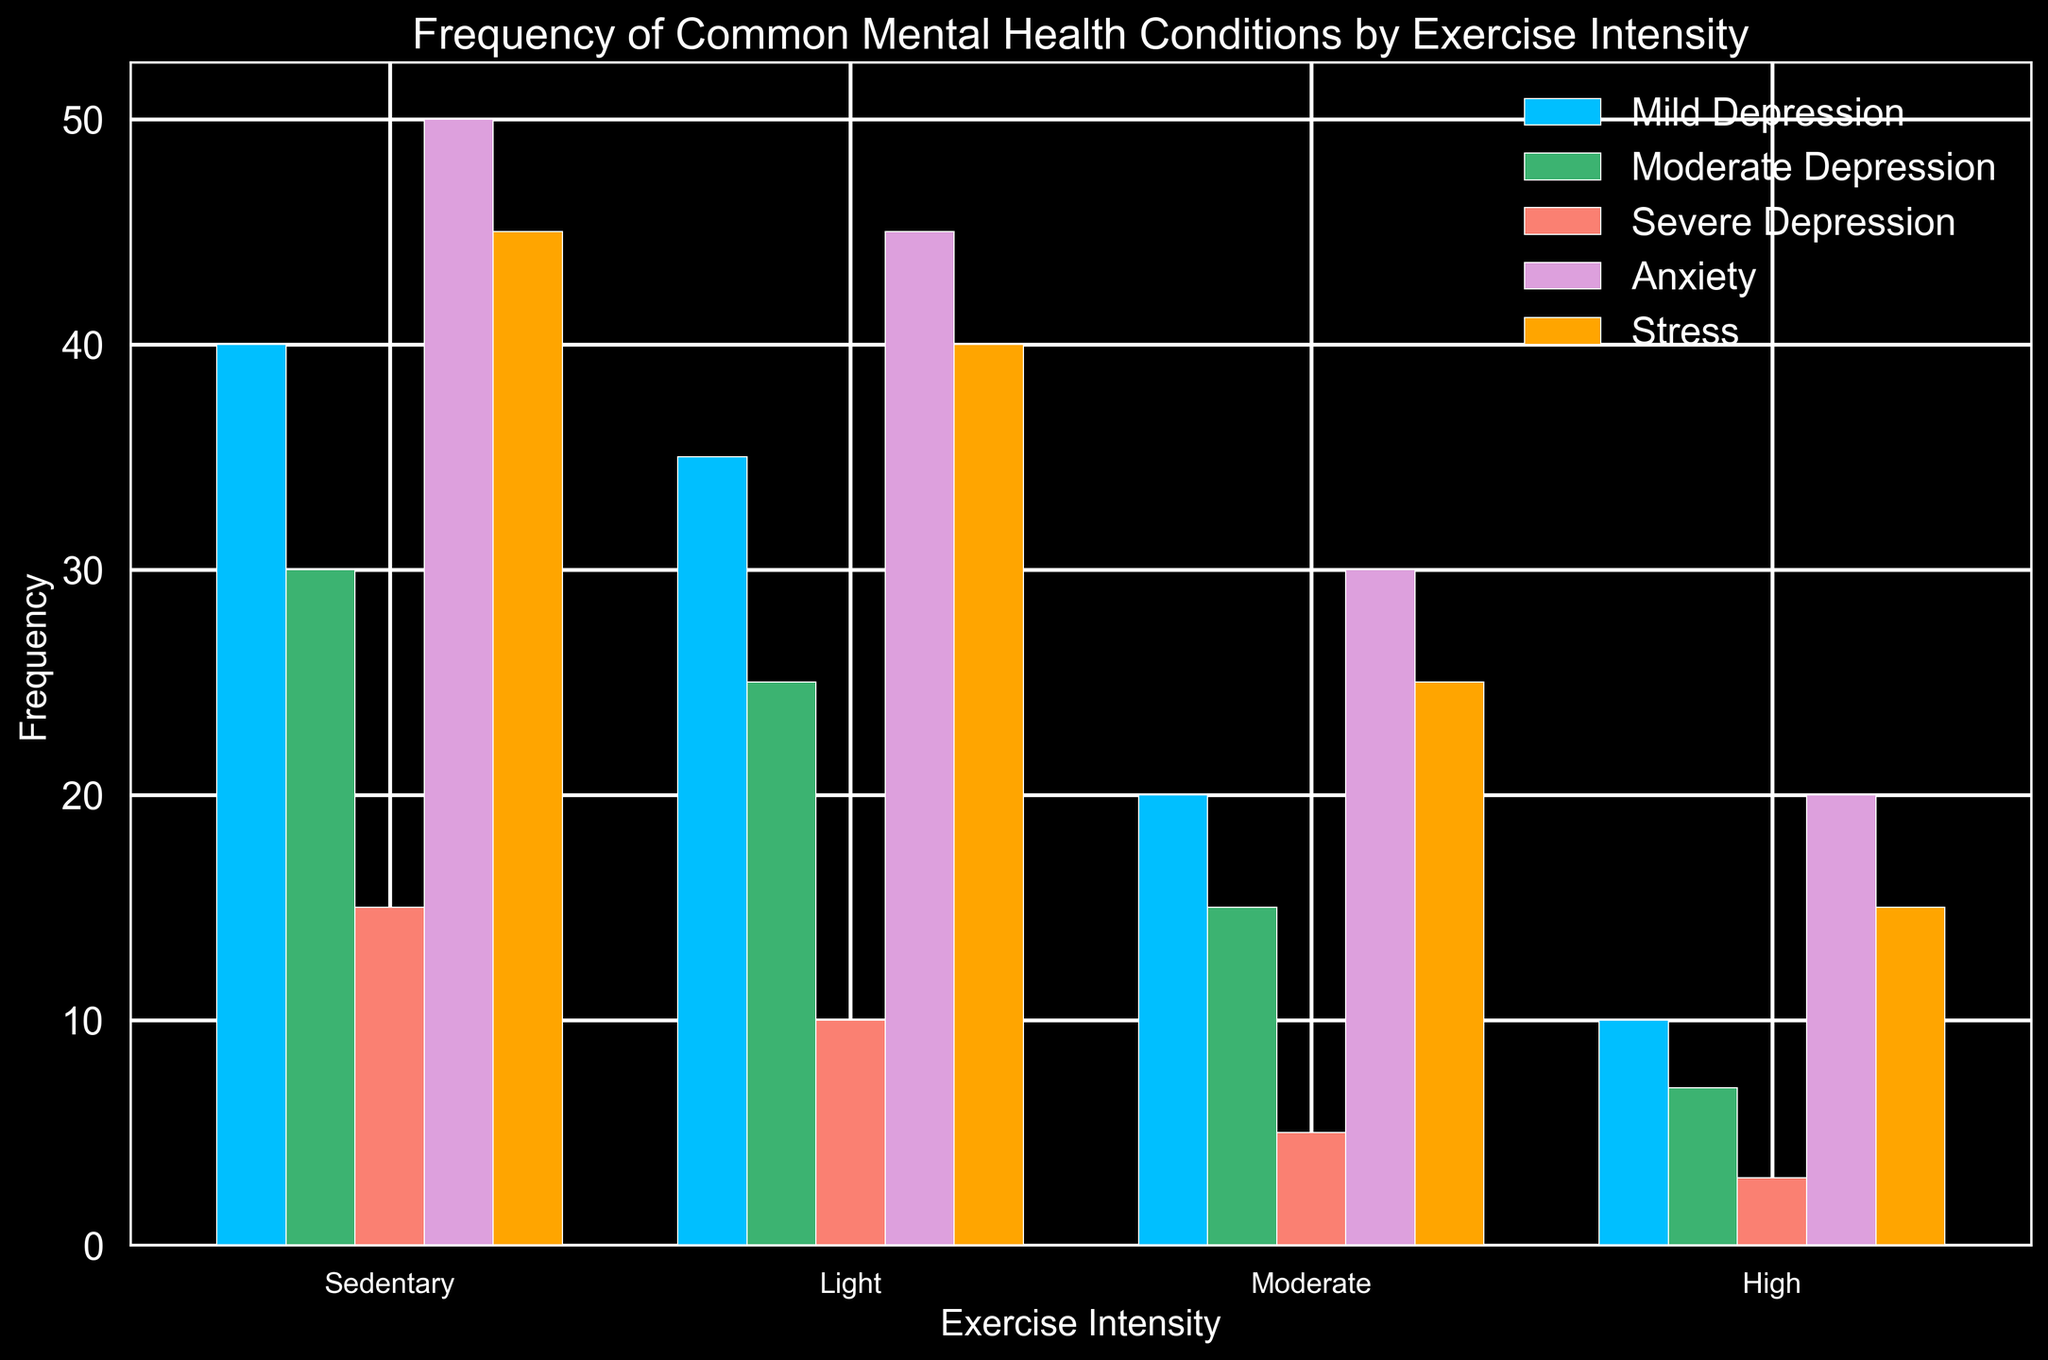What is the trend in the frequency of anxiety as exercise intensity increases? The height of the light purple bars that represent anxiety diminishes as exercise intensity increases from sedentary to high intensity. Specifically, anxiety frequency decreases from 50 in sedentary to 20 in high intensity.
Answer: Anxiety frequency decreases as exercise intensity increases Which exercise intensity level has the highest frequency of mild depression? The blue bars represent mild depression, and the sedentary group has the tallest blue bar with a frequency of 40.
Answer: Sedentary How does the frequency of moderate depression in the sedentary group compare to that in the high-intensity group? The green bars represent moderate depression. In the sedentary group, the frequency is 30, while the high-intensity group has a frequency of 7.
Answer: Sedentary is higher What is the difference in stress frequency between light and high exercise intensity groups? The orange bars indicate stress frequency. The light intensity group has a frequency of 40, and the high-intensity group has a frequency of 15. The difference is 40 - 15 = 25.
Answer: 25 Among the different exercise intensities, which mental health condition shows the greatest overall decline in frequency from sedentary to high intensity? By comparing the total height of the bars from sedentary to high intensity for each mental health condition, it's clear that 'Anxiety' drops from 50 to 20, a decline of 30. This is the largest overall decline compared to mild depression, moderate depression, severe depression, and stress.
Answer: Anxiety What is the average frequency of severe depression across all exercise intensities? The red bars represent severe depression. The frequencies across the exercise intensities are 15, 10, 5, and 3. The average is calculated as (15 + 10 + 5 + 3) / 4 = 8.25.
Answer: 8.25 Which exercise intensity has the lowest stress frequency? The orange bars indicate stress, and the high-intensity group has the shortest bar with a frequency of 15.
Answer: High Compare the frequency of mild depression to stress in the moderate exercise intensity group. In the moderate intensity group, the blue bar (mild depression) has a frequency of 20, while the orange bar (stress) has a frequency of 25.
Answer: Stress is higher What is the combined frequency of moderate and severe depression in the light exercise intensity group? The green bar represents moderate depression with a frequency of 25, and the red bar represents severe depression with a frequency of 10. The combined frequency is 25 + 10 = 35.
Answer: 35 Which color represents anxiety, and what is its frequency at light exercise intensity? The light purple bars represent anxiety. At light exercise intensity, the frequency is represented by the second light purple bar from the left which has a frequency of 45.
Answer: Light purple, 45 